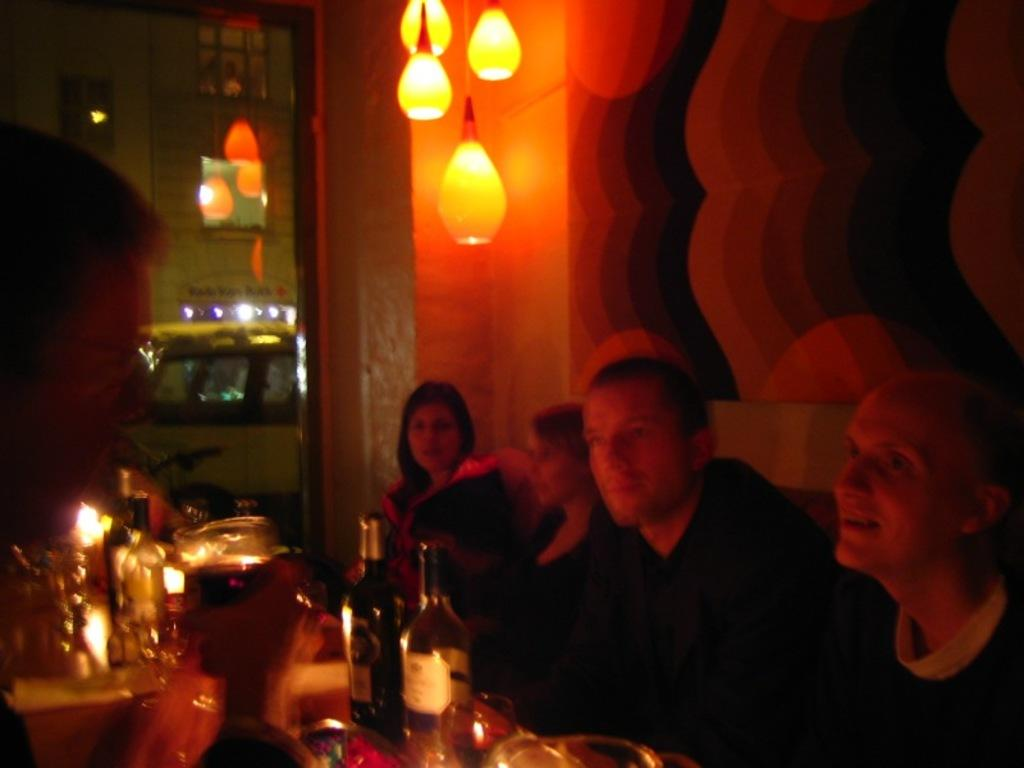What are the people in the image doing? The people in the image are seated. What objects can be seen on the table in the image? There are bottles and glasses on the table in the image. What is located on the top of the roof in the image? There are lights on the top of the roof in the image. Can you tell me how many cows are present in the image? There are no cows present in the image. What type of book is being read by the person in the image? There is no book present in the image. 